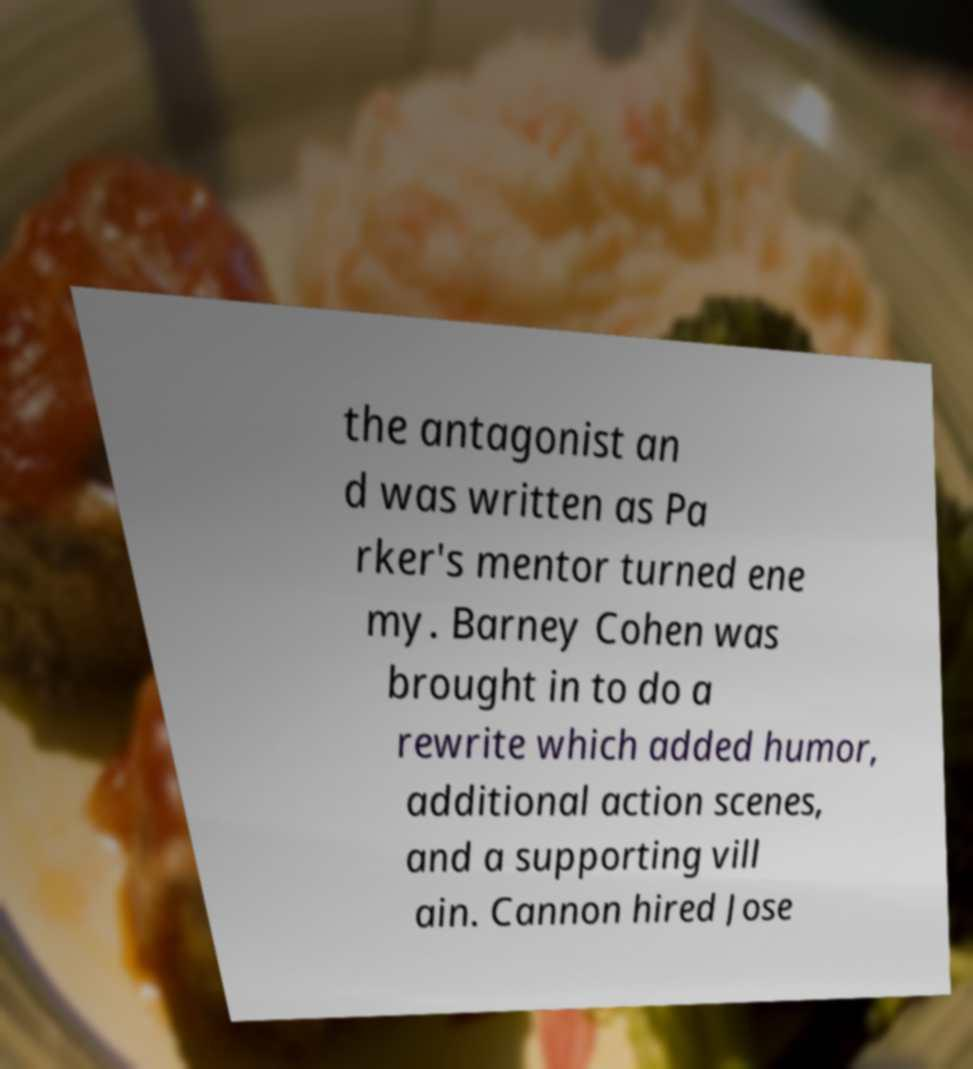For documentation purposes, I need the text within this image transcribed. Could you provide that? the antagonist an d was written as Pa rker's mentor turned ene my. Barney Cohen was brought in to do a rewrite which added humor, additional action scenes, and a supporting vill ain. Cannon hired Jose 